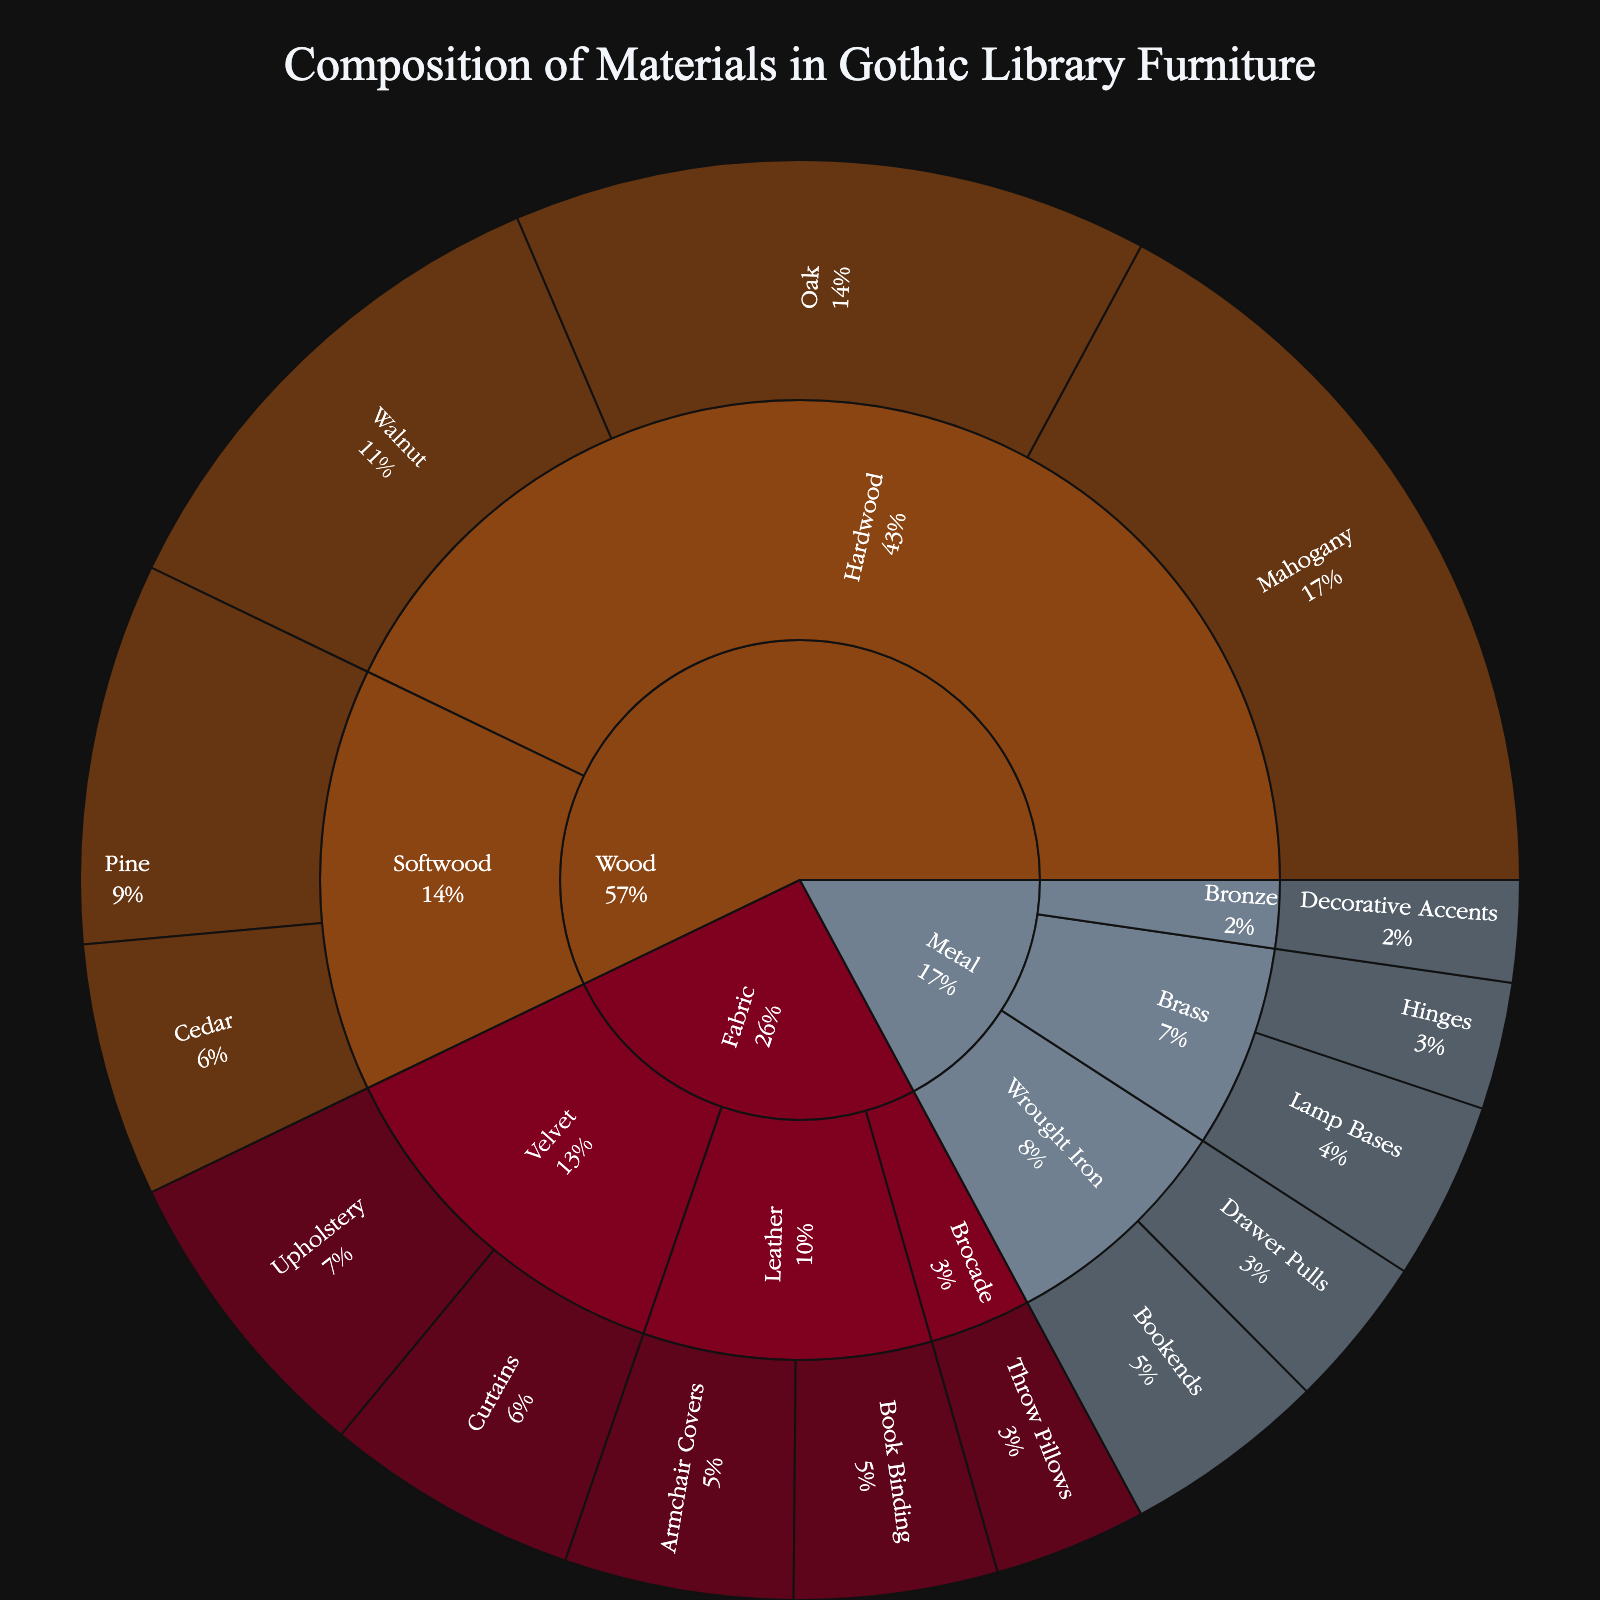What's the title of the figure? The title of the figure is usually displayed prominently at the top of the visualization. In this case, it is "Composition of Materials in Gothic Library Furniture."
Answer: Composition of Materials in Gothic Library Furniture What type of wood has the highest value? The sunburst plot shows different categories and subcategories of materials. By examining the segments under the 'Wood' category, we can see that 'Hardwood' has the highest value among types of wood, specifically 'Mahogany' within hardwoods.
Answer: Mahogany Which category has the smallest contribution to the composition? By looking at the outer edges of the sunburst plot, we can determine the sections with the smallest visual representation. The 'Metal' category has smaller individual values compared to 'Wood' and 'Fabric'. Within 'Metal', the 'Bronze' subcategory has the smallest contribution.
Answer: Bronze How does the value of Mahogany compare to that of Oak? To find this, we locate both items within the 'Hardwood' subcategory in the 'Wood' category. Mahogany has a value of 30 and Oak has a value of 25. Therefore, Mahogany has a higher value than Oak.
Answer: Mahogany > Oak What is the cumulative value of the 'Velvet' subcategory? We need to sum the values of all items in the 'Velvet' subcategory of the 'Fabric' category: Upholstery (12) + Curtains (10). Adding these equals 22.
Answer: 22 What are the values of all items in the 'Wrought Iron' subcategory? Within the 'Metal' category, locate the 'Wrought Iron' subcategory. It contains 'Bookends' with a value of 8 and 'Drawer Pulls' with a value of 6.
Answer: Bookends: 8, Drawer Pulls: 6 Compare the overall contributions of 'Hardwood' and 'Softwood' within the 'Wood' category. Which is higher? Summing the values within each type: Hardwood (Mahogany: 30 + Oak: 25 + Walnut: 20) = 75, Softwood (Pine: 15 + Cedar: 10) = 25. Hardwood has a higher overall contribution.
Answer: Hardwood Which has a greater value, 'Fabric' used in 'Armchair Covers' or in 'Book Binding'? Both items are under the 'Leather' subcategory in 'Fabric'. Armchair Covers has a value of 9 while Book Binding has a value of 8. Armchair Covers' value is higher.
Answer: Armchair Covers What is the percentage contribution of 'Mahogany' in the overall 'Wood' category? First, calculate the total value of the 'Wood' category: 30 (Mahogany) + 25 (Oak) + 20 (Walnut) + 15 (Pine) + 10 (Cedar) = 100. The percentage for Mahogany is (30/100) * 100% = 30%.
Answer: 30% Which item in the 'Metal' category has the lowest value? By examining the 'Metal' category, we can identify the lowest value item. 'Decorative Accents' in 'Bronze' has the lowest value at 4.
Answer: Decorative Accents 